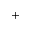<formula> <loc_0><loc_0><loc_500><loc_500>^ { + }</formula> 